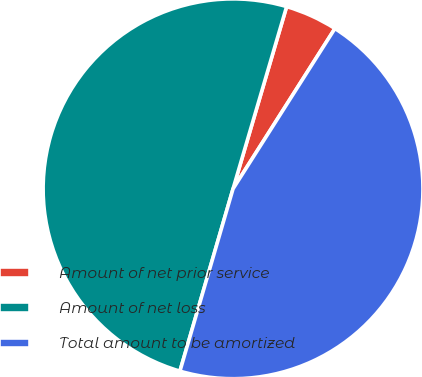<chart> <loc_0><loc_0><loc_500><loc_500><pie_chart><fcel>Amount of net prior service<fcel>Amount of net loss<fcel>Total amount to be amortized<nl><fcel>4.46%<fcel>50.04%<fcel>45.5%<nl></chart> 